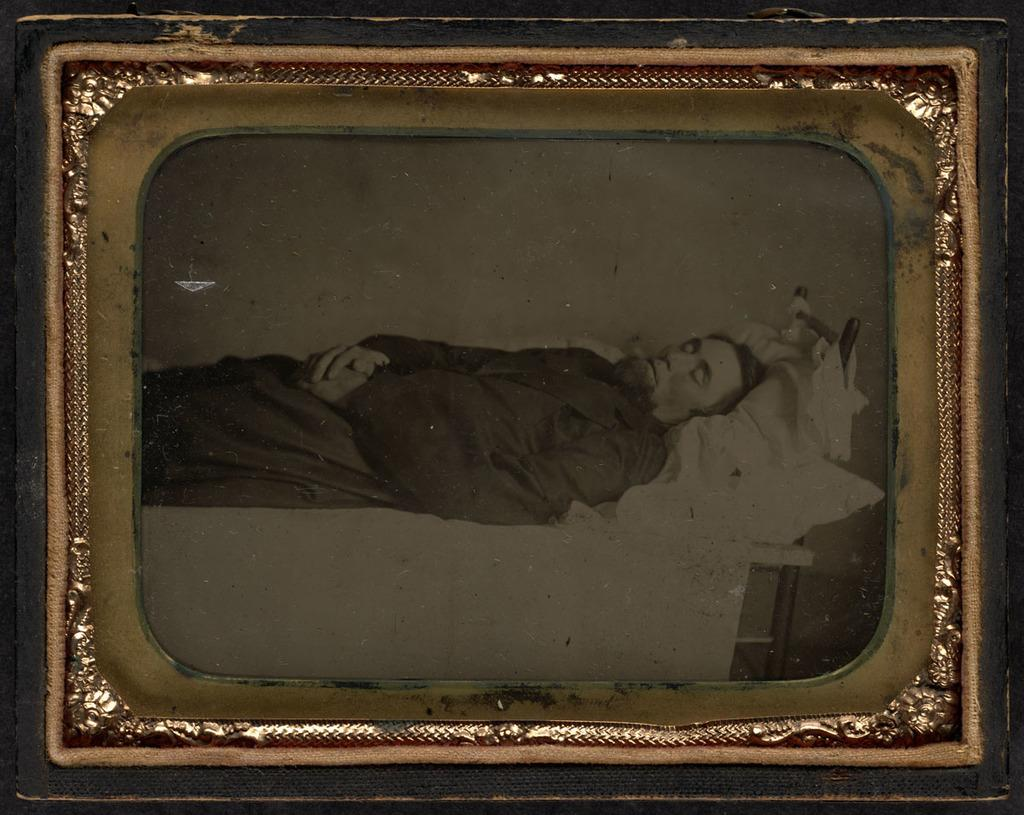What object is present in the image that typically holds a photograph? There is a photo frame in the image. What is happening with the person in the photo frame? A person is standing in the photo frame. What type of disease is the person in the photo frame suffering from? There is no indication of any disease in the image, as it only shows a person standing in a photo frame. 